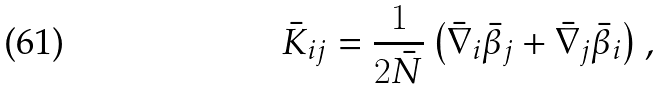<formula> <loc_0><loc_0><loc_500><loc_500>\bar { K } _ { i j } = \frac { 1 } { 2 \bar { N } } \left ( \bar { \nabla } _ { i } \bar { \beta } _ { j } + \bar { \nabla } _ { j } \bar { \beta } _ { i } \right ) ,</formula> 